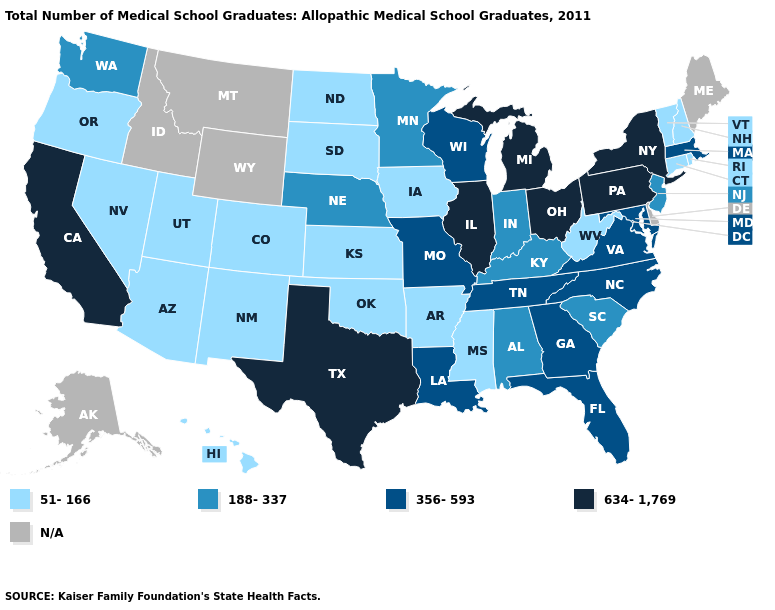Does Ohio have the lowest value in the USA?
Quick response, please. No. What is the value of Alaska?
Short answer required. N/A. Which states have the highest value in the USA?
Quick response, please. California, Illinois, Michigan, New York, Ohio, Pennsylvania, Texas. Name the states that have a value in the range 51-166?
Answer briefly. Arizona, Arkansas, Colorado, Connecticut, Hawaii, Iowa, Kansas, Mississippi, Nevada, New Hampshire, New Mexico, North Dakota, Oklahoma, Oregon, Rhode Island, South Dakota, Utah, Vermont, West Virginia. What is the highest value in states that border Iowa?
Write a very short answer. 634-1,769. Does Texas have the highest value in the South?
Write a very short answer. Yes. What is the value of Indiana?
Concise answer only. 188-337. What is the value of Wyoming?
Concise answer only. N/A. Name the states that have a value in the range 188-337?
Answer briefly. Alabama, Indiana, Kentucky, Minnesota, Nebraska, New Jersey, South Carolina, Washington. Which states have the highest value in the USA?
Short answer required. California, Illinois, Michigan, New York, Ohio, Pennsylvania, Texas. Is the legend a continuous bar?
Quick response, please. No. Which states have the lowest value in the MidWest?
Be succinct. Iowa, Kansas, North Dakota, South Dakota. 